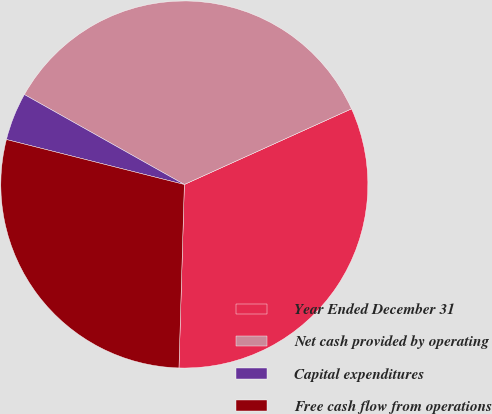<chart> <loc_0><loc_0><loc_500><loc_500><pie_chart><fcel>Year Ended December 31<fcel>Net cash provided by operating<fcel>Capital expenditures<fcel>Free cash flow from operations<nl><fcel>32.23%<fcel>35.08%<fcel>4.21%<fcel>28.47%<nl></chart> 